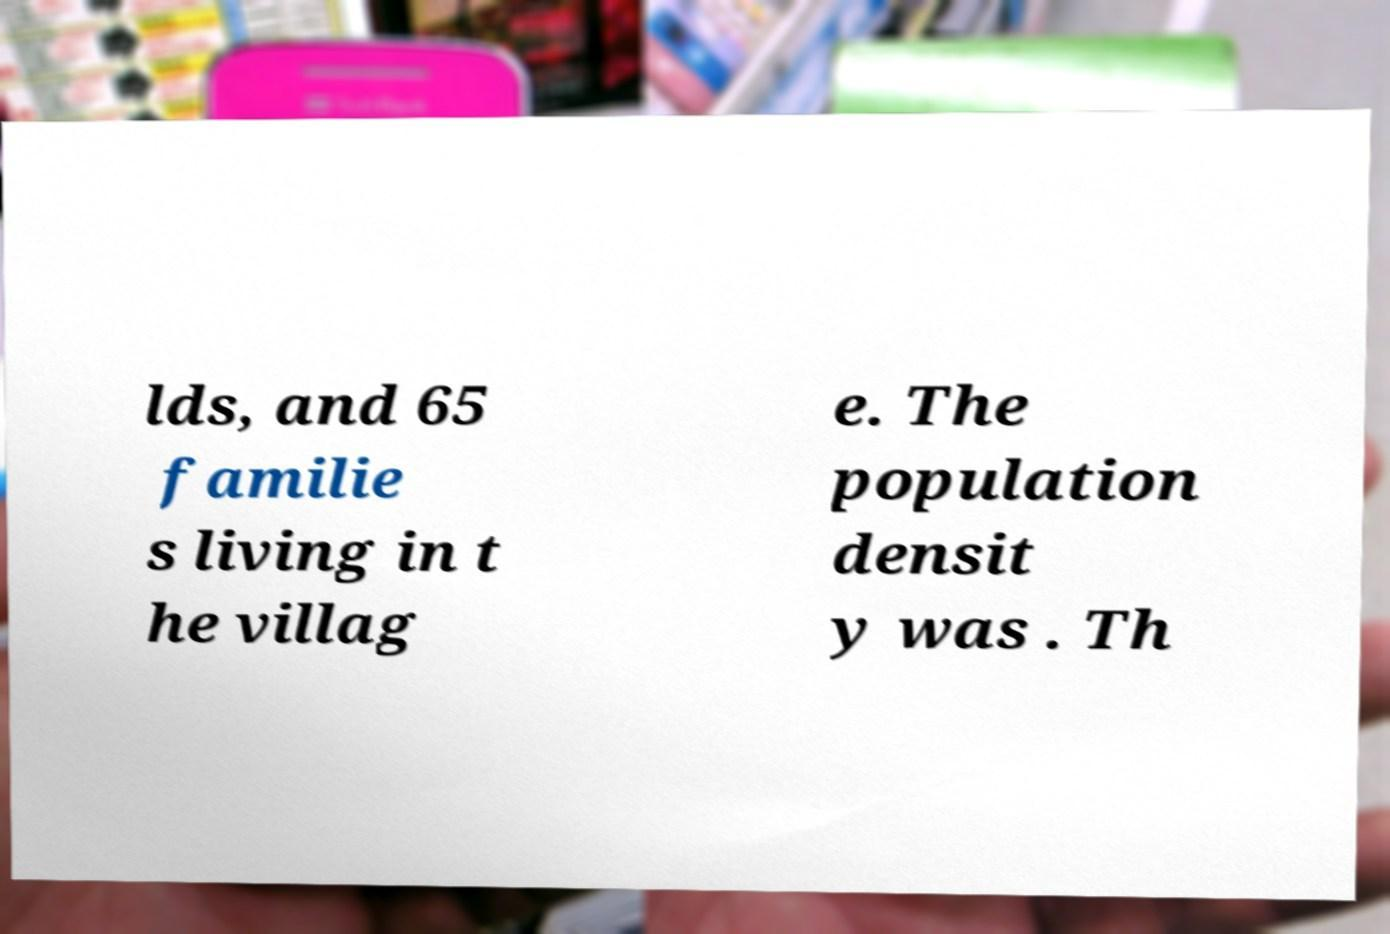There's text embedded in this image that I need extracted. Can you transcribe it verbatim? lds, and 65 familie s living in t he villag e. The population densit y was . Th 